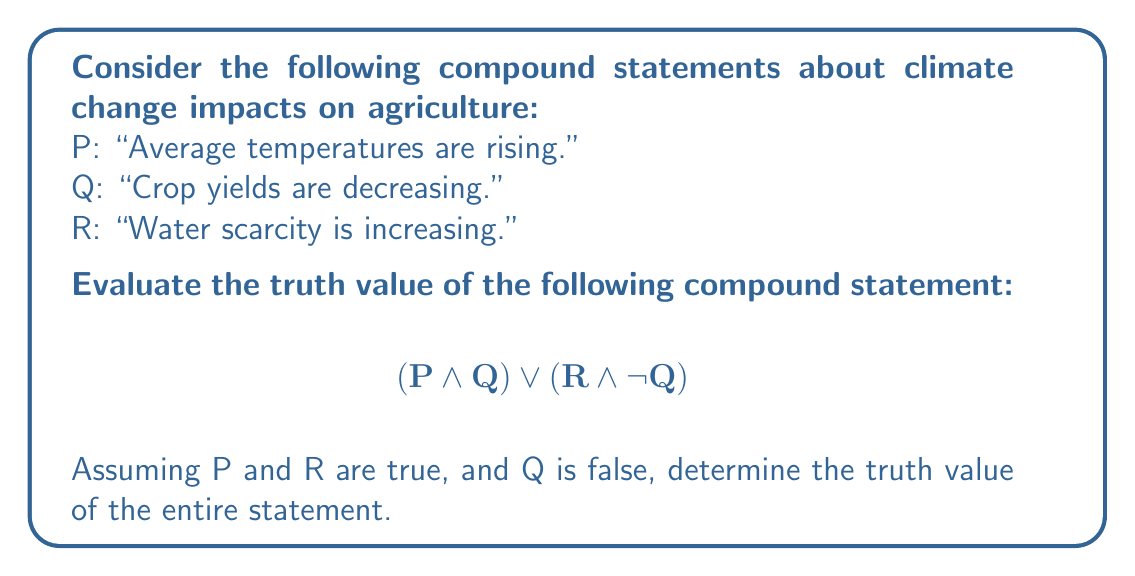Can you solve this math problem? Let's break this down step-by-step:

1) We are given that:
   P is true (T)
   Q is false (F)
   R is true (T)

2) Let's evaluate each part of the compound statement:

   a) $(P \land Q)$:
      This is a conjunction (AND) operation.
      $T \land F = F$

   b) $(R \land \lnot Q)$:
      First, we need to evaluate $\lnot Q$:
      $\lnot F = T$
      Now, we have:
      $T \land T = T$

3) Now our statement looks like this:
   $F \lor T$

4) This is a disjunction (OR) operation:
   $F \lor T = T$

Therefore, the entire compound statement evaluates to true.

This result makes sense in the context of climate change and agriculture. Even though crop yields are not decreasing (Q is false), the statement is still true because water scarcity is increasing (R is true) while crop yields are not decreasing ($\lnot Q$ is true). This highlights the complex nature of climate change impacts on agriculture, where some factors may be worsening while others are not (yet) showing negative effects.
Answer: True 